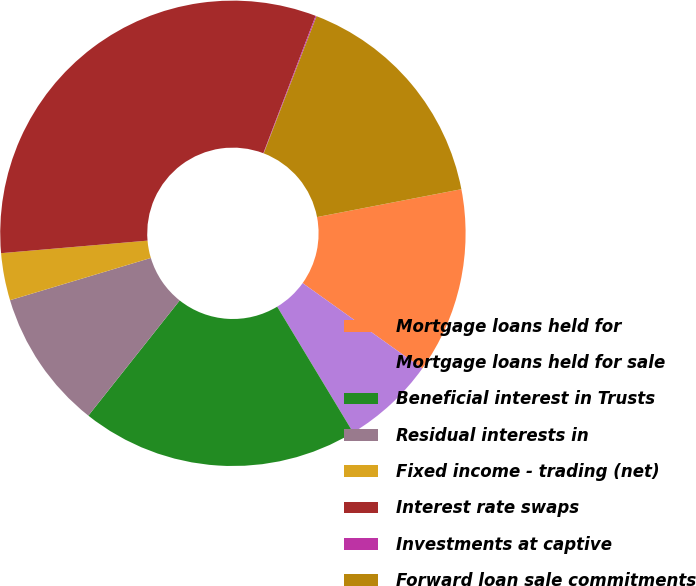Convert chart. <chart><loc_0><loc_0><loc_500><loc_500><pie_chart><fcel>Mortgage loans held for<fcel>Mortgage loans held for sale<fcel>Beneficial interest in Trusts<fcel>Residual interests in<fcel>Fixed income - trading (net)<fcel>Interest rate swaps<fcel>Investments at captive<fcel>Forward loan sale commitments<nl><fcel>12.9%<fcel>6.49%<fcel>19.31%<fcel>9.69%<fcel>3.28%<fcel>32.14%<fcel>0.07%<fcel>16.11%<nl></chart> 